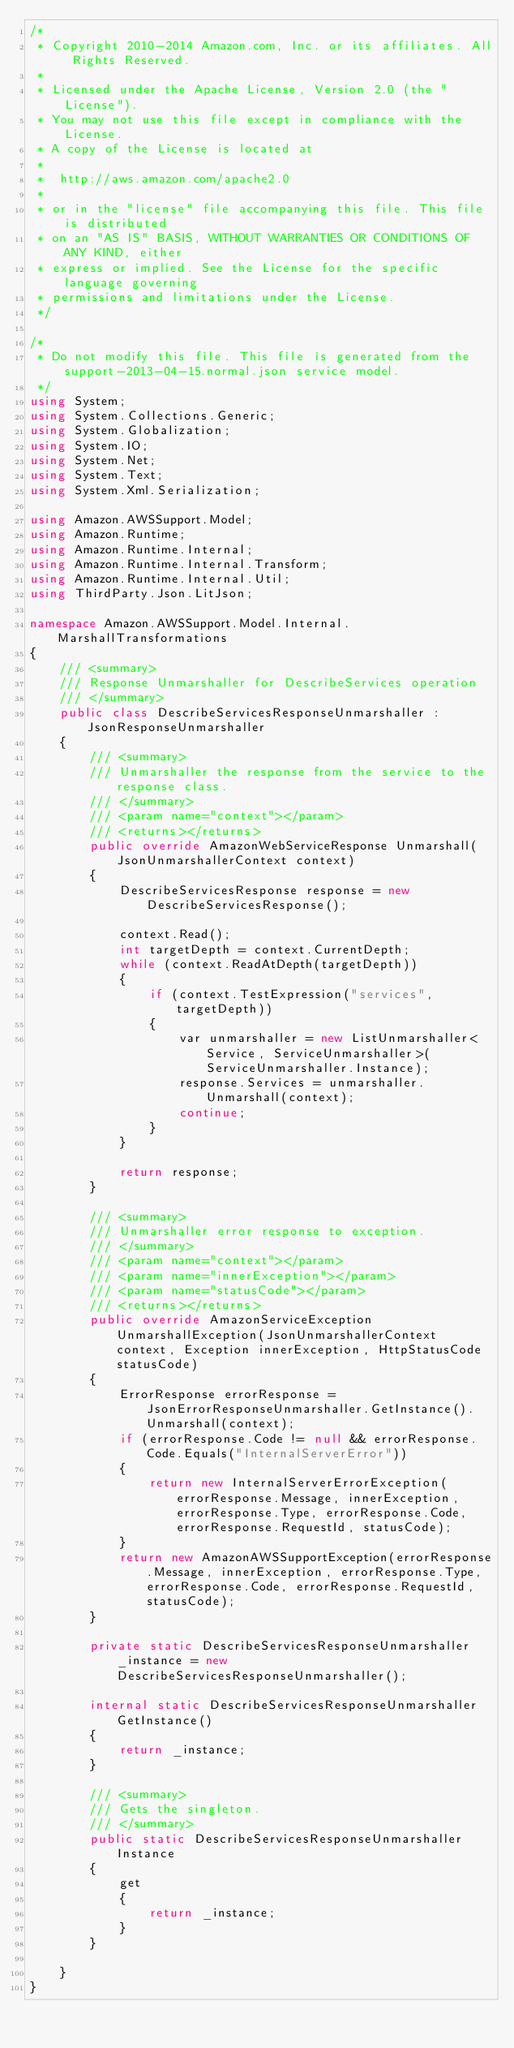Convert code to text. <code><loc_0><loc_0><loc_500><loc_500><_C#_>/*
 * Copyright 2010-2014 Amazon.com, Inc. or its affiliates. All Rights Reserved.
 * 
 * Licensed under the Apache License, Version 2.0 (the "License").
 * You may not use this file except in compliance with the License.
 * A copy of the License is located at
 * 
 *  http://aws.amazon.com/apache2.0
 * 
 * or in the "license" file accompanying this file. This file is distributed
 * on an "AS IS" BASIS, WITHOUT WARRANTIES OR CONDITIONS OF ANY KIND, either
 * express or implied. See the License for the specific language governing
 * permissions and limitations under the License.
 */

/*
 * Do not modify this file. This file is generated from the support-2013-04-15.normal.json service model.
 */
using System;
using System.Collections.Generic;
using System.Globalization;
using System.IO;
using System.Net;
using System.Text;
using System.Xml.Serialization;

using Amazon.AWSSupport.Model;
using Amazon.Runtime;
using Amazon.Runtime.Internal;
using Amazon.Runtime.Internal.Transform;
using Amazon.Runtime.Internal.Util;
using ThirdParty.Json.LitJson;

namespace Amazon.AWSSupport.Model.Internal.MarshallTransformations
{
    /// <summary>
    /// Response Unmarshaller for DescribeServices operation
    /// </summary>  
    public class DescribeServicesResponseUnmarshaller : JsonResponseUnmarshaller
    {
        /// <summary>
        /// Unmarshaller the response from the service to the response class.
        /// </summary>  
        /// <param name="context"></param>
        /// <returns></returns>
        public override AmazonWebServiceResponse Unmarshall(JsonUnmarshallerContext context)
        {
            DescribeServicesResponse response = new DescribeServicesResponse();

            context.Read();
            int targetDepth = context.CurrentDepth;
            while (context.ReadAtDepth(targetDepth))
            {
                if (context.TestExpression("services", targetDepth))
                {
                    var unmarshaller = new ListUnmarshaller<Service, ServiceUnmarshaller>(ServiceUnmarshaller.Instance);
                    response.Services = unmarshaller.Unmarshall(context);
                    continue;
                }
            }

            return response;
        }

        /// <summary>
        /// Unmarshaller error response to exception.
        /// </summary>  
        /// <param name="context"></param>
        /// <param name="innerException"></param>
        /// <param name="statusCode"></param>
        /// <returns></returns>
        public override AmazonServiceException UnmarshallException(JsonUnmarshallerContext context, Exception innerException, HttpStatusCode statusCode)
        {
            ErrorResponse errorResponse = JsonErrorResponseUnmarshaller.GetInstance().Unmarshall(context);
            if (errorResponse.Code != null && errorResponse.Code.Equals("InternalServerError"))
            {
                return new InternalServerErrorException(errorResponse.Message, innerException, errorResponse.Type, errorResponse.Code, errorResponse.RequestId, statusCode);
            }
            return new AmazonAWSSupportException(errorResponse.Message, innerException, errorResponse.Type, errorResponse.Code, errorResponse.RequestId, statusCode);
        }

        private static DescribeServicesResponseUnmarshaller _instance = new DescribeServicesResponseUnmarshaller();        

        internal static DescribeServicesResponseUnmarshaller GetInstance()
        {
            return _instance;
        }

        /// <summary>
        /// Gets the singleton.
        /// </summary>  
        public static DescribeServicesResponseUnmarshaller Instance
        {
            get
            {
                return _instance;
            }
        }

    }
}</code> 